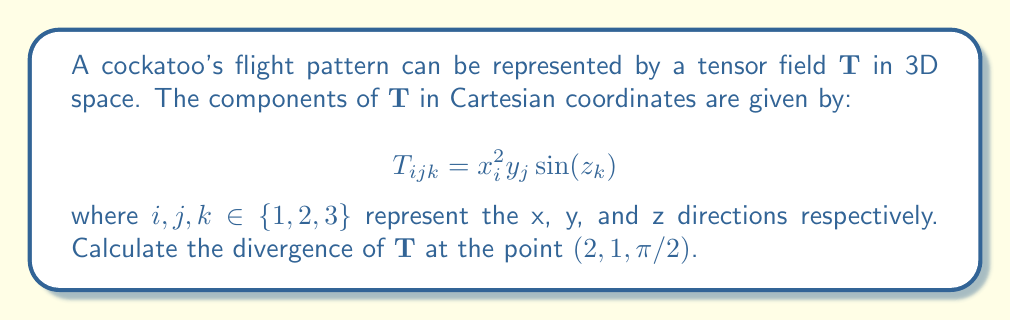Can you answer this question? To solve this problem, we need to follow these steps:

1) The divergence of a third-order tensor field $\mathbf{T}$ in 3D space is given by:

   $$\text{div}\mathbf{T} = \frac{\partial T_{ijk}}{\partial x_k}$$

   where we sum over the repeated index $k$.

2) We need to calculate:

   $$\text{div}\mathbf{T} = \frac{\partial T_{ij1}}{\partial x_1} + \frac{\partial T_{ij2}}{\partial x_2} + \frac{\partial T_{ij3}}{\partial x_3}$$

3) Let's calculate each term:

   $$\frac{\partial T_{ij1}}{\partial x_1} = \frac{\partial (x_i^2y_j\sin(z_1))}{\partial x_1} = 0$$
   
   $$\frac{\partial T_{ij2}}{\partial x_2} = \frac{\partial (x_i^2y_j\sin(z_2))}{\partial x_2} = 0$$
   
   $$\frac{\partial T_{ij3}}{\partial x_3} = \frac{\partial (x_i^2y_j\sin(z_3))}{\partial x_3} = x_i^2y_j\cos(z_3)$$

4) Therefore, 

   $$\text{div}\mathbf{T} = x_i^2y_j\cos(z_3)$$

5) At the point $(2,1,\pi/2)$:

   $$\text{div}\mathbf{T} = 2^2 \cdot 1 \cdot \cos(\pi/2) = 4 \cdot 0 = 0$$
Answer: 0 